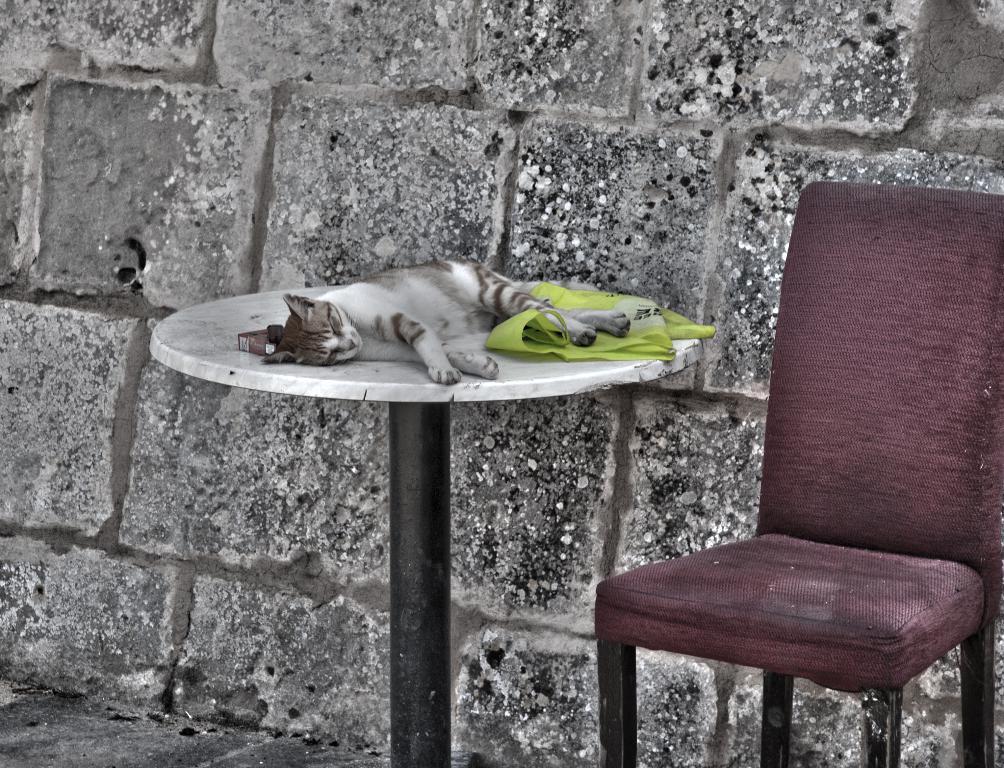Can you describe this image briefly? This cat is sleeping on this table. This is a red chair. 